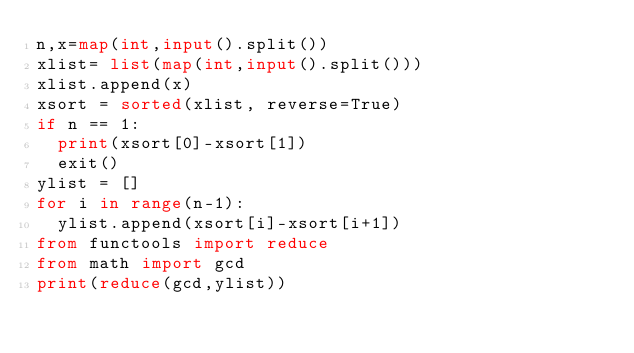<code> <loc_0><loc_0><loc_500><loc_500><_Python_>n,x=map(int,input().split())
xlist= list(map(int,input().split()))
xlist.append(x)
xsort = sorted(xlist, reverse=True)
if n == 1:
  print(xsort[0]-xsort[1])
  exit()
ylist = []
for i in range(n-1):
  ylist.append(xsort[i]-xsort[i+1])
from functools import reduce
from math import gcd
print(reduce(gcd,ylist))</code> 